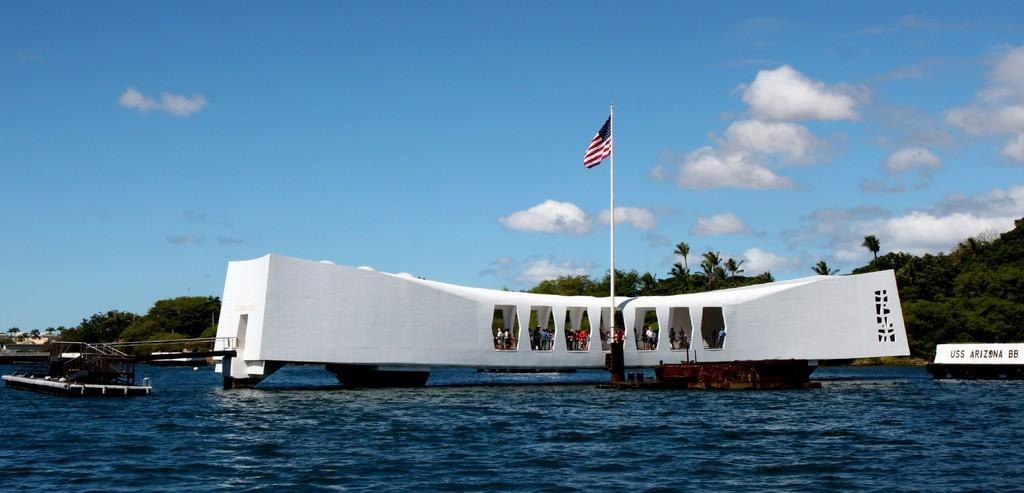<image>
Render a clear and concise summary of the photo. The tourists are visiting the Pearl Harbor USS Arizona. 